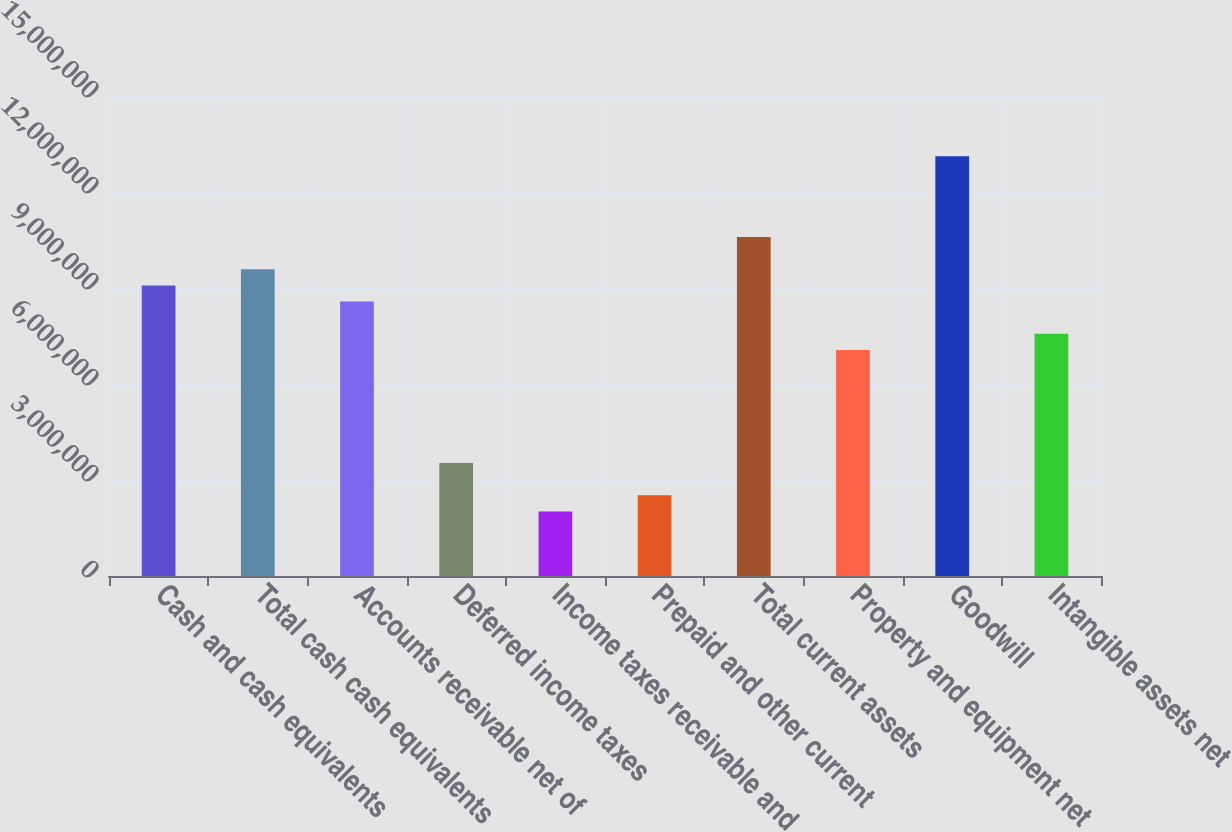Convert chart to OTSL. <chart><loc_0><loc_0><loc_500><loc_500><bar_chart><fcel>Cash and cash equivalents<fcel>Total cash cash equivalents<fcel>Accounts receivable net of<fcel>Deferred income taxes<fcel>Income taxes receivable and<fcel>Prepaid and other current<fcel>Total current assets<fcel>Property and equipment net<fcel>Goodwill<fcel>Intangible assets net<nl><fcel>9.08109e+06<fcel>9.58551e+06<fcel>8.57667e+06<fcel>3.53248e+06<fcel>2.01923e+06<fcel>2.52365e+06<fcel>1.05943e+07<fcel>7.06341e+06<fcel>1.31164e+07<fcel>7.56783e+06<nl></chart> 